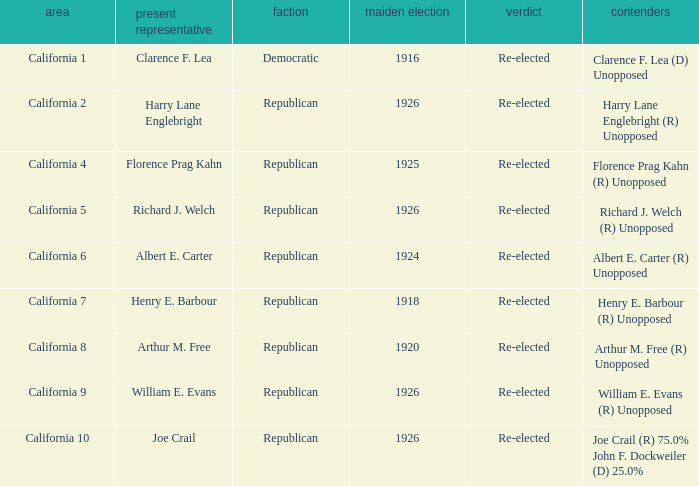 how many candidates with district being california 7 1.0. 